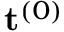<formula> <loc_0><loc_0><loc_500><loc_500>t ^ { ( 0 ) }</formula> 